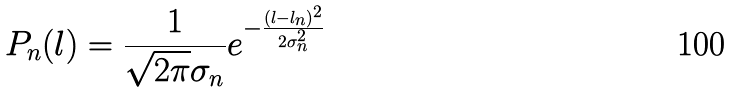<formula> <loc_0><loc_0><loc_500><loc_500>P _ { n } ( l ) = \frac { 1 } { \sqrt { 2 \pi } \sigma _ { n } } e ^ { - \frac { ( l - l _ { n } ) ^ { 2 } } { 2 \sigma _ { n } ^ { 2 } } }</formula> 